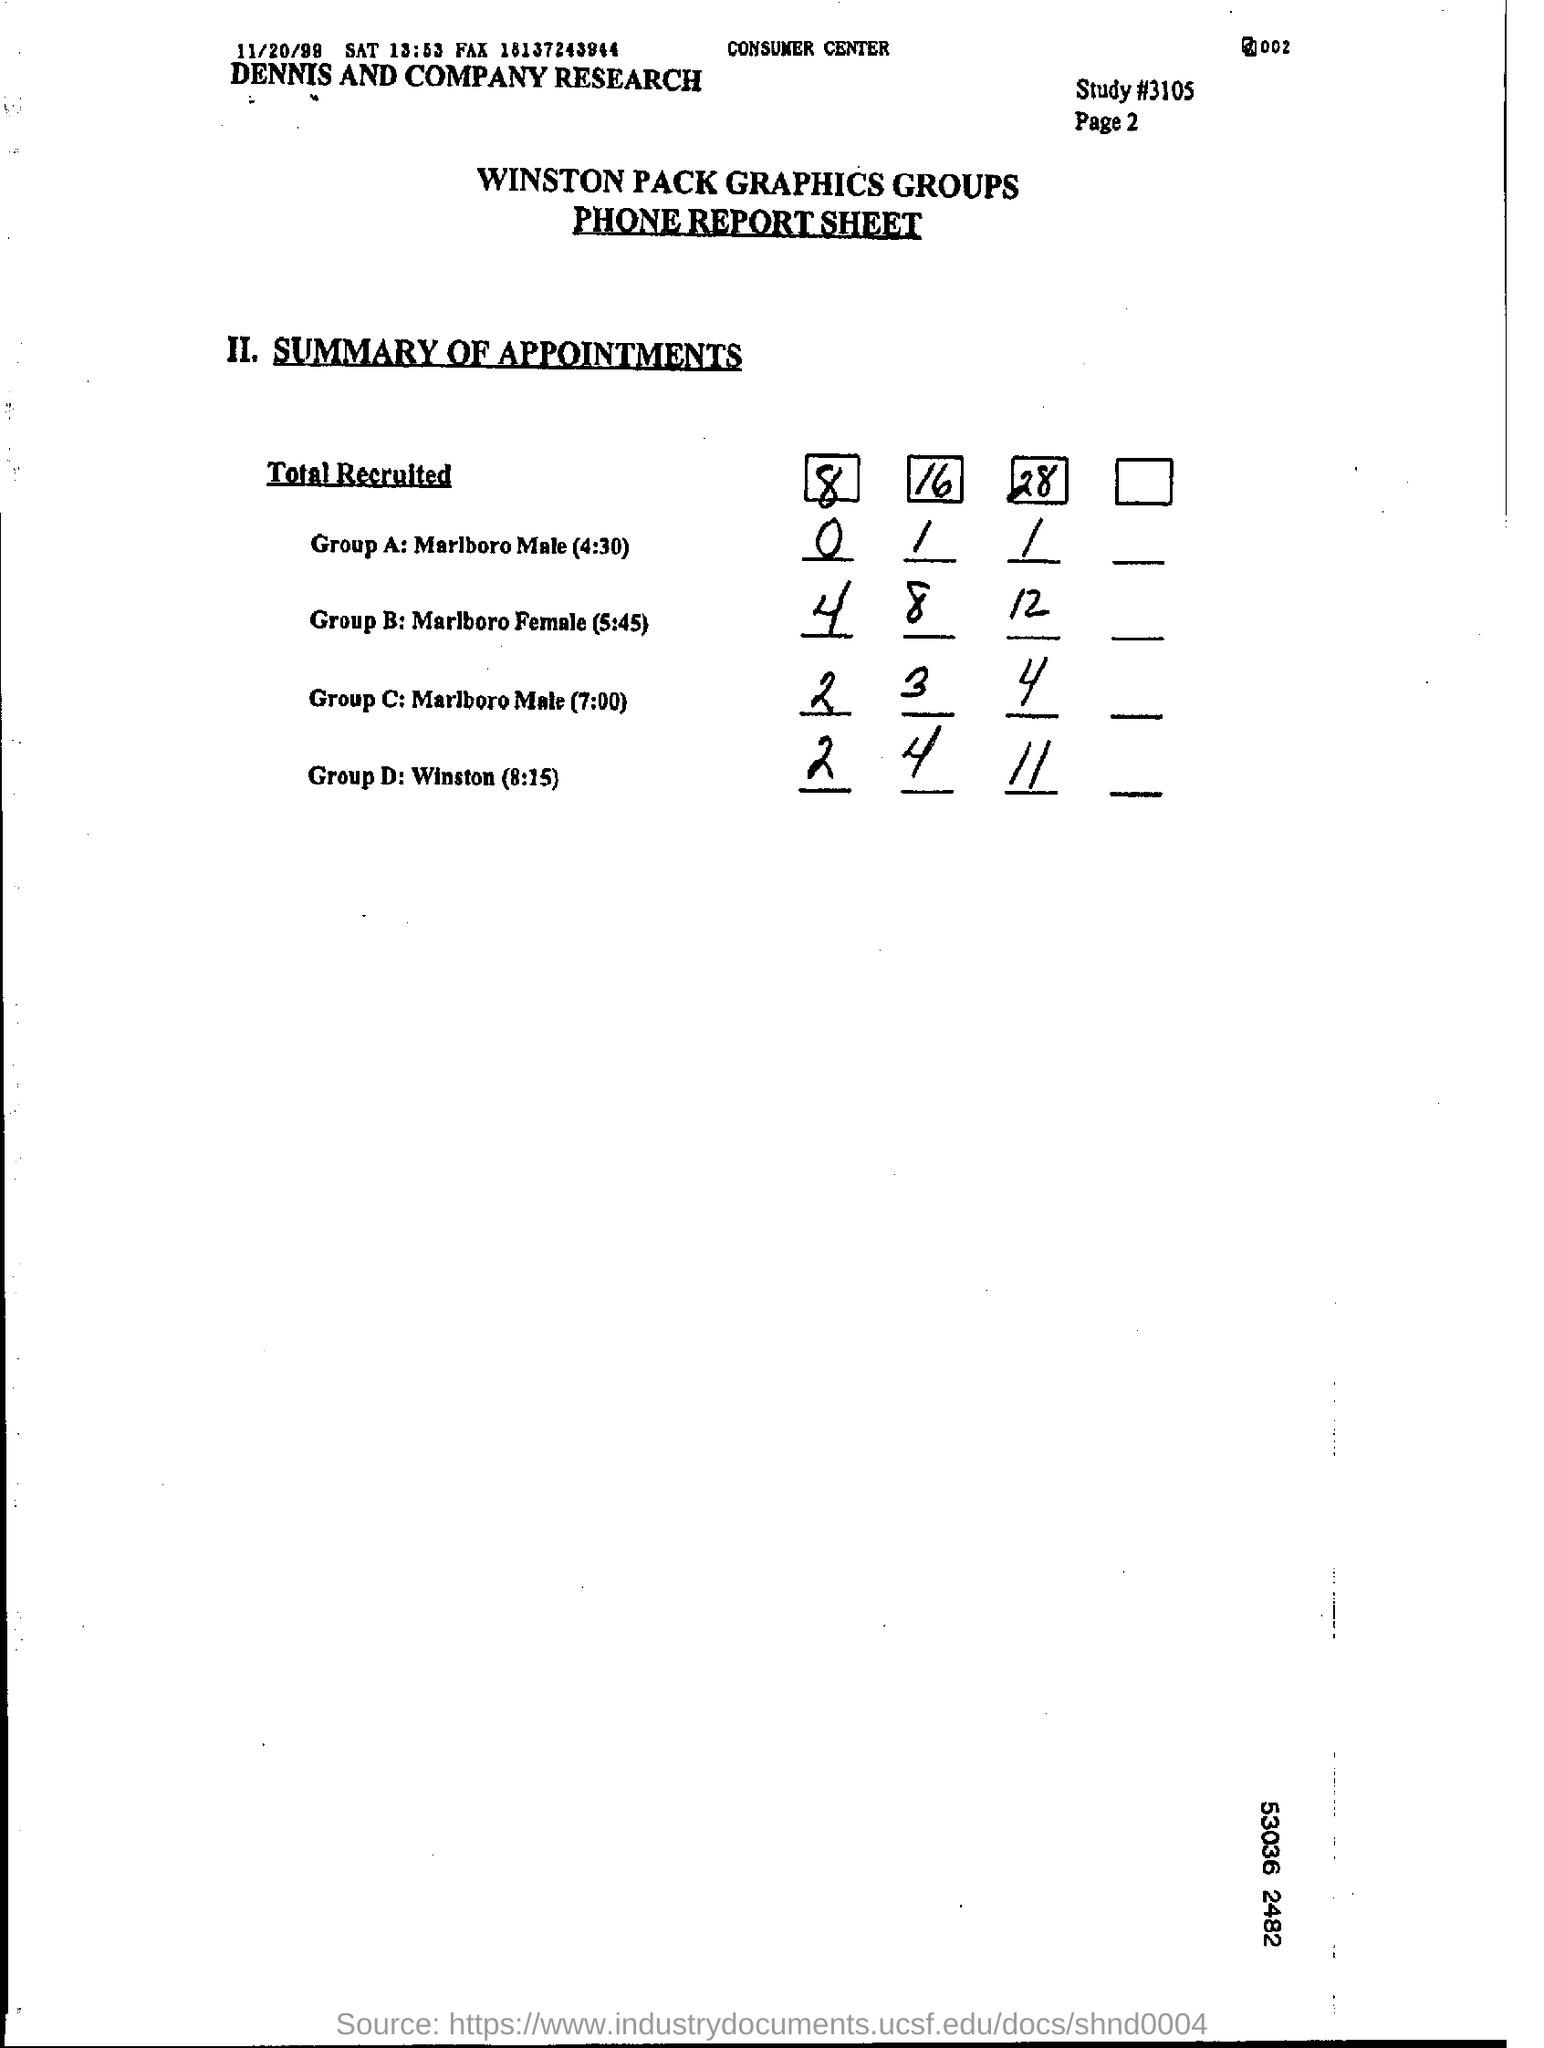Indicate a few pertinent items in this graphic. The report sheet in question is a phone report sheet. The name of the group is Winston Pack Graphics Group. The group under the title 'total recruited' is named 'D'. The code for the study is #3105. Under the title 'Total Recruited,' the group named Marlboro Male is listed. 